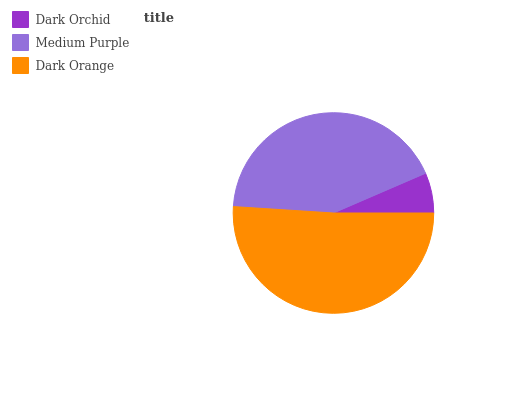Is Dark Orchid the minimum?
Answer yes or no. Yes. Is Dark Orange the maximum?
Answer yes or no. Yes. Is Medium Purple the minimum?
Answer yes or no. No. Is Medium Purple the maximum?
Answer yes or no. No. Is Medium Purple greater than Dark Orchid?
Answer yes or no. Yes. Is Dark Orchid less than Medium Purple?
Answer yes or no. Yes. Is Dark Orchid greater than Medium Purple?
Answer yes or no. No. Is Medium Purple less than Dark Orchid?
Answer yes or no. No. Is Medium Purple the high median?
Answer yes or no. Yes. Is Medium Purple the low median?
Answer yes or no. Yes. Is Dark Orange the high median?
Answer yes or no. No. Is Dark Orchid the low median?
Answer yes or no. No. 